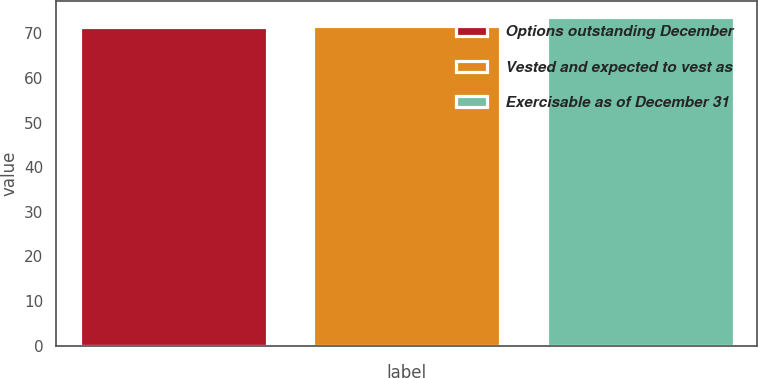<chart> <loc_0><loc_0><loc_500><loc_500><bar_chart><fcel>Options outstanding December<fcel>Vested and expected to vest as<fcel>Exercisable as of December 31<nl><fcel>71.5<fcel>71.71<fcel>73.6<nl></chart> 